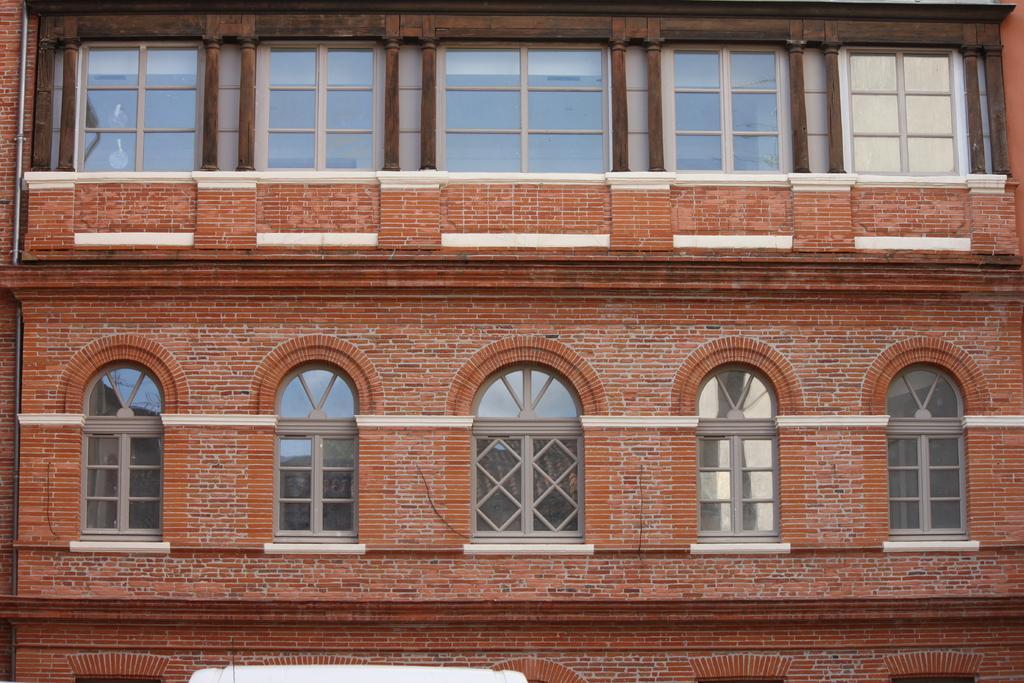How would you summarize this image in a sentence or two? In this picture I can see some windows to the building. 